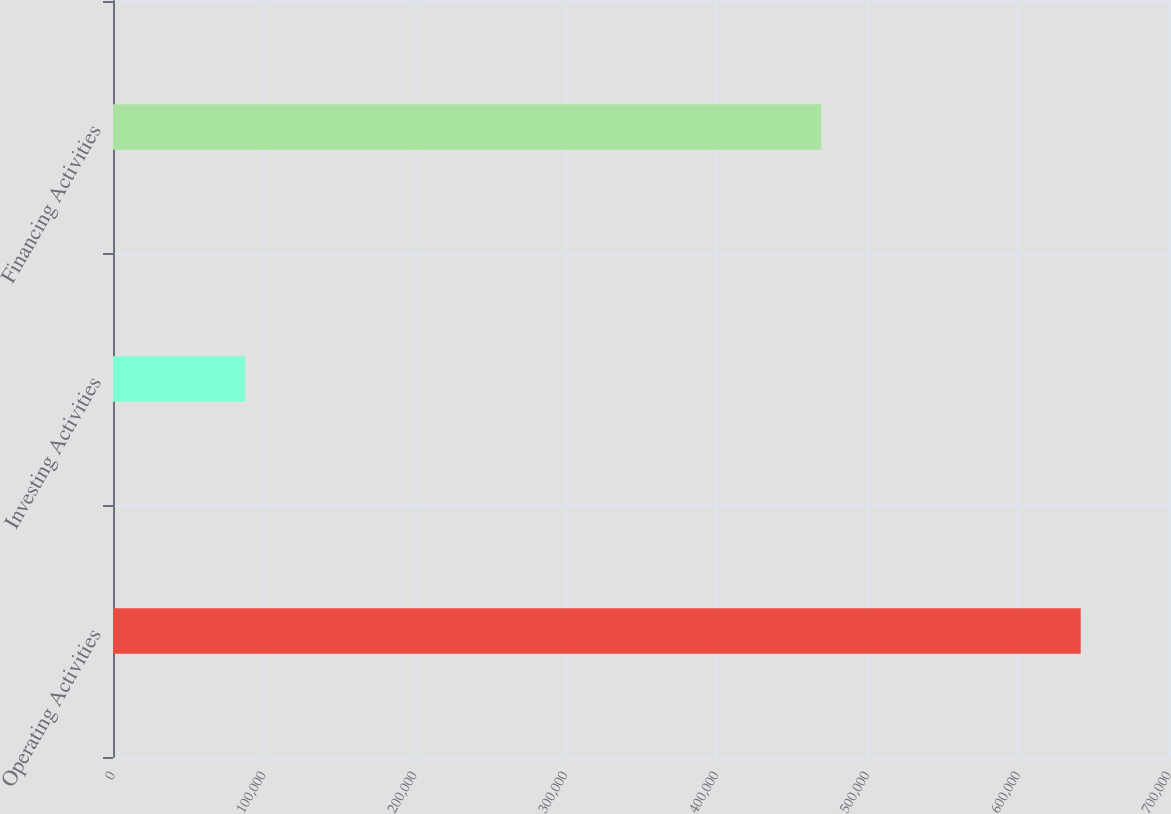Convert chart to OTSL. <chart><loc_0><loc_0><loc_500><loc_500><bar_chart><fcel>Operating Activities<fcel>Investing Activities<fcel>Financing Activities<nl><fcel>641471<fcel>87598<fcel>469496<nl></chart> 